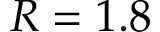Convert formula to latex. <formula><loc_0><loc_0><loc_500><loc_500>R = 1 . 8</formula> 